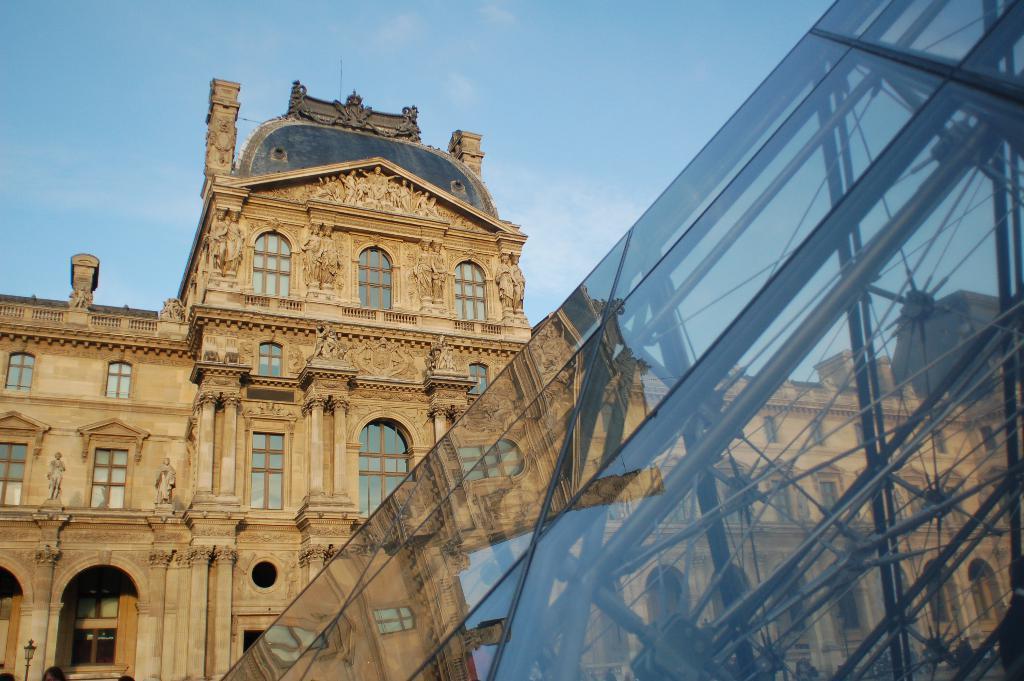Can you describe this image briefly? In the picture there is a huge construction, it is a beautiful building with many carvings and windows and there is some class equipment in the front. 